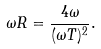<formula> <loc_0><loc_0><loc_500><loc_500>\omega R = \frac { 4 \omega } { ( \omega T ) ^ { 2 } } .</formula> 